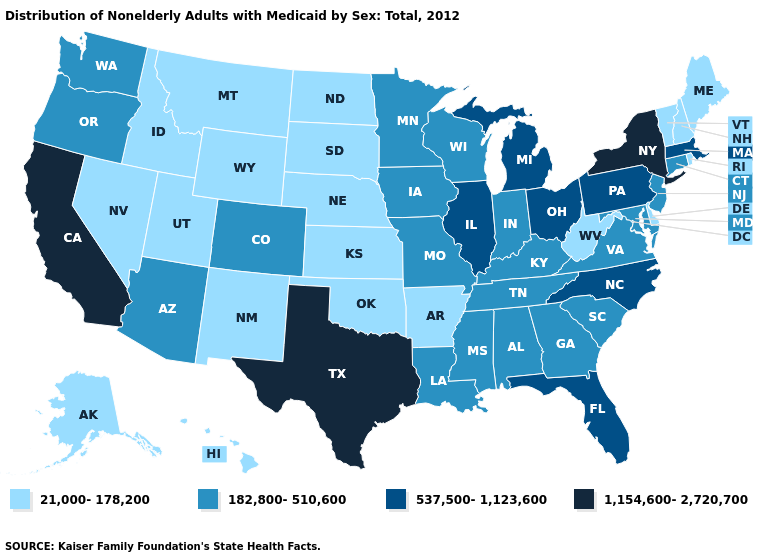What is the value of Idaho?
Be succinct. 21,000-178,200. What is the value of Washington?
Be succinct. 182,800-510,600. Name the states that have a value in the range 21,000-178,200?
Answer briefly. Alaska, Arkansas, Delaware, Hawaii, Idaho, Kansas, Maine, Montana, Nebraska, Nevada, New Hampshire, New Mexico, North Dakota, Oklahoma, Rhode Island, South Dakota, Utah, Vermont, West Virginia, Wyoming. What is the value of New York?
Concise answer only. 1,154,600-2,720,700. Among the states that border West Virginia , which have the lowest value?
Write a very short answer. Kentucky, Maryland, Virginia. What is the lowest value in the West?
Be succinct. 21,000-178,200. How many symbols are there in the legend?
Quick response, please. 4. Name the states that have a value in the range 537,500-1,123,600?
Answer briefly. Florida, Illinois, Massachusetts, Michigan, North Carolina, Ohio, Pennsylvania. Name the states that have a value in the range 182,800-510,600?
Answer briefly. Alabama, Arizona, Colorado, Connecticut, Georgia, Indiana, Iowa, Kentucky, Louisiana, Maryland, Minnesota, Mississippi, Missouri, New Jersey, Oregon, South Carolina, Tennessee, Virginia, Washington, Wisconsin. What is the lowest value in the South?
Answer briefly. 21,000-178,200. What is the lowest value in the West?
Be succinct. 21,000-178,200. What is the lowest value in the USA?
Be succinct. 21,000-178,200. What is the value of California?
Keep it brief. 1,154,600-2,720,700. Name the states that have a value in the range 537,500-1,123,600?
Quick response, please. Florida, Illinois, Massachusetts, Michigan, North Carolina, Ohio, Pennsylvania. What is the highest value in the West ?
Be succinct. 1,154,600-2,720,700. 